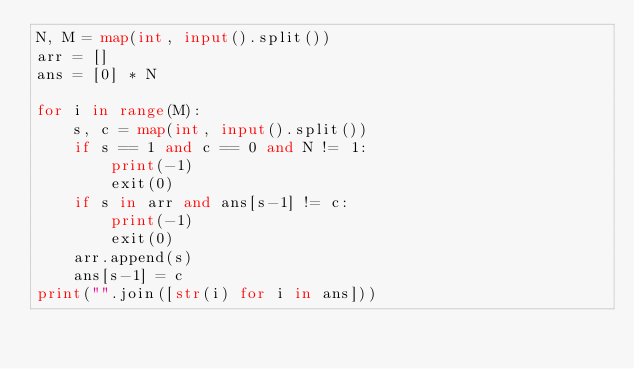Convert code to text. <code><loc_0><loc_0><loc_500><loc_500><_Python_>N, M = map(int, input().split())
arr = []
ans = [0] * N

for i in range(M):
    s, c = map(int, input().split())
    if s == 1 and c == 0 and N != 1:
        print(-1)
        exit(0)
    if s in arr and ans[s-1] != c:
        print(-1)
        exit(0)
    arr.append(s)
    ans[s-1] = c
print("".join([str(i) for i in ans]))
</code> 